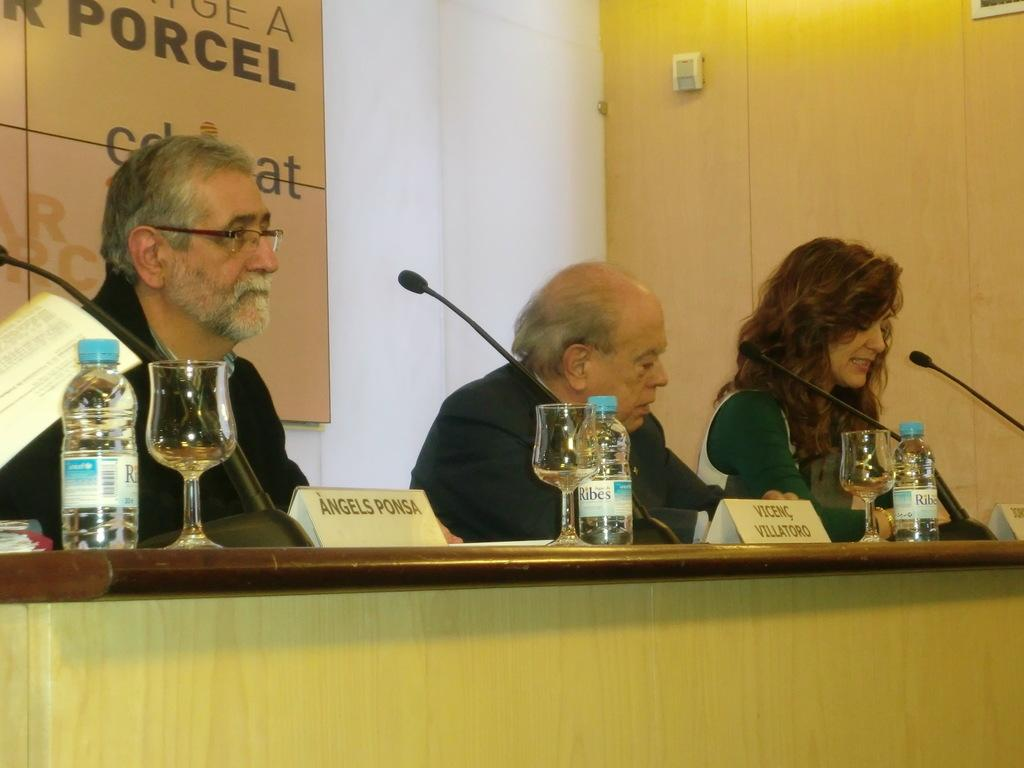<image>
Give a short and clear explanation of the subsequent image. the name angels is on the sign in front of the man 